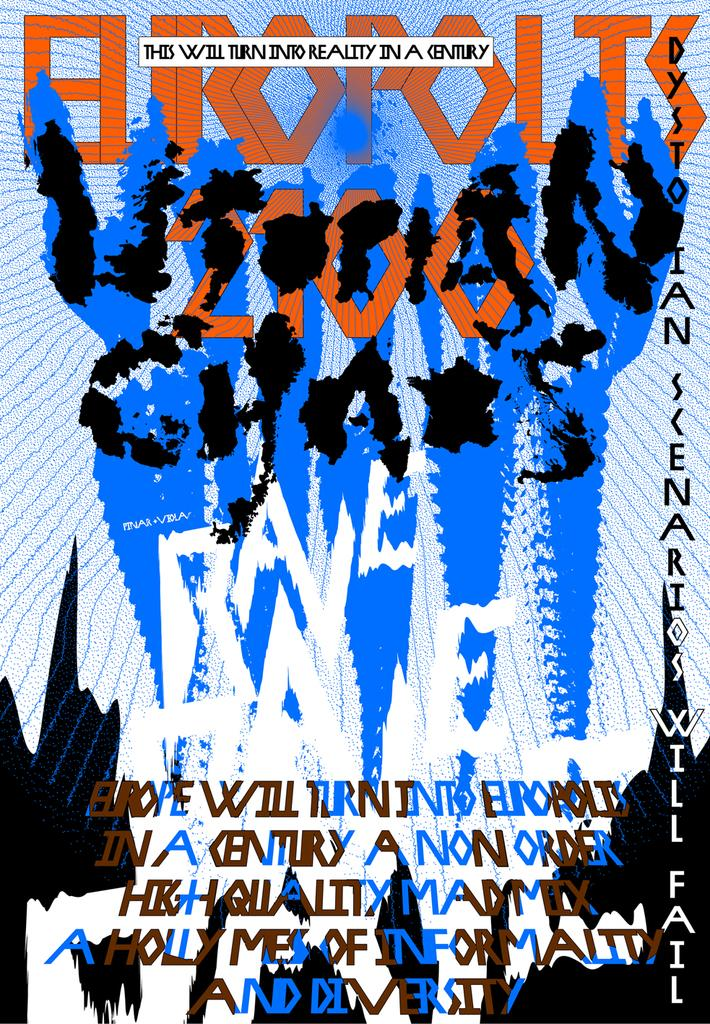What is the main subject of the image? The main subject of the image is the cover of a book. What type of paste is being used by the beggar on the monkey in the image? There is no beggar or monkey present in the image, and therefore no such activity can be observed. 